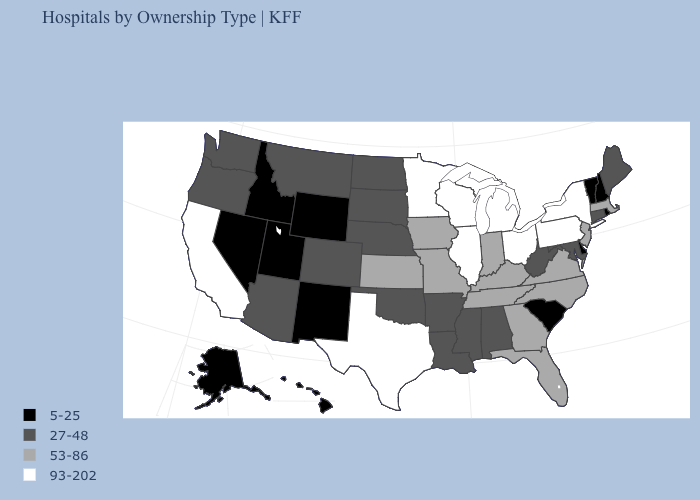What is the value of New Jersey?
Be succinct. 53-86. Which states have the lowest value in the MidWest?
Quick response, please. Nebraska, North Dakota, South Dakota. Does Louisiana have a higher value than South Carolina?
Write a very short answer. Yes. Is the legend a continuous bar?
Short answer required. No. What is the value of Ohio?
Quick response, please. 93-202. Name the states that have a value in the range 27-48?
Short answer required. Alabama, Arizona, Arkansas, Colorado, Connecticut, Louisiana, Maine, Maryland, Mississippi, Montana, Nebraska, North Dakota, Oklahoma, Oregon, South Dakota, Washington, West Virginia. What is the lowest value in states that border Delaware?
Keep it brief. 27-48. What is the value of Oklahoma?
Write a very short answer. 27-48. What is the lowest value in the Northeast?
Give a very brief answer. 5-25. Name the states that have a value in the range 53-86?
Write a very short answer. Florida, Georgia, Indiana, Iowa, Kansas, Kentucky, Massachusetts, Missouri, New Jersey, North Carolina, Tennessee, Virginia. Which states have the lowest value in the South?
Quick response, please. Delaware, South Carolina. Among the states that border South Dakota , does Wyoming have the highest value?
Answer briefly. No. Does the map have missing data?
Answer briefly. No. Among the states that border Maryland , which have the highest value?
Short answer required. Pennsylvania. Which states hav the highest value in the West?
Answer briefly. California. 